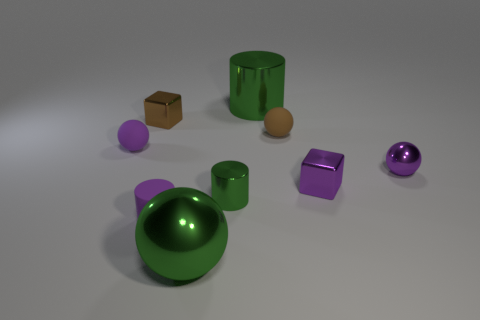Subtract 1 balls. How many balls are left? 3 Subtract all cubes. How many objects are left? 7 Add 5 small purple metallic blocks. How many small purple metallic blocks are left? 6 Add 6 tiny purple cubes. How many tiny purple cubes exist? 7 Subtract 0 brown cylinders. How many objects are left? 9 Subtract all yellow rubber balls. Subtract all brown balls. How many objects are left? 8 